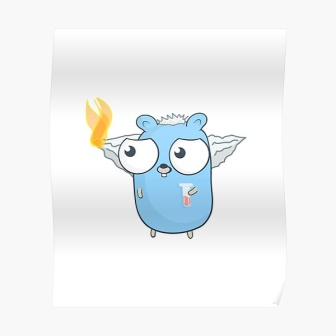In a burst of whimsy, describe what this creature's dreams might look like. In the dreams of this captivating creature, colors dance in an endless sky of azure and gold. It soars freely with its wings, gliding through fluffy clouds that taste like spun sugar. The flame upon its head ignites not just with heat but with visions of fantastical realms; floating islands where trees sing melodious tunes, and rivers flow with sparkling stardust. It meets other whimsical beings—talking otters with top hats, and glow-in-the-dark mushrooms that tell stories of ancient times. In these dreams, the creature feels boundless, unchained by earthly ailments, and delights in a world where imagination knows no limits, and joy bubbles up just like the effervescent streams of Whispering Woods. 